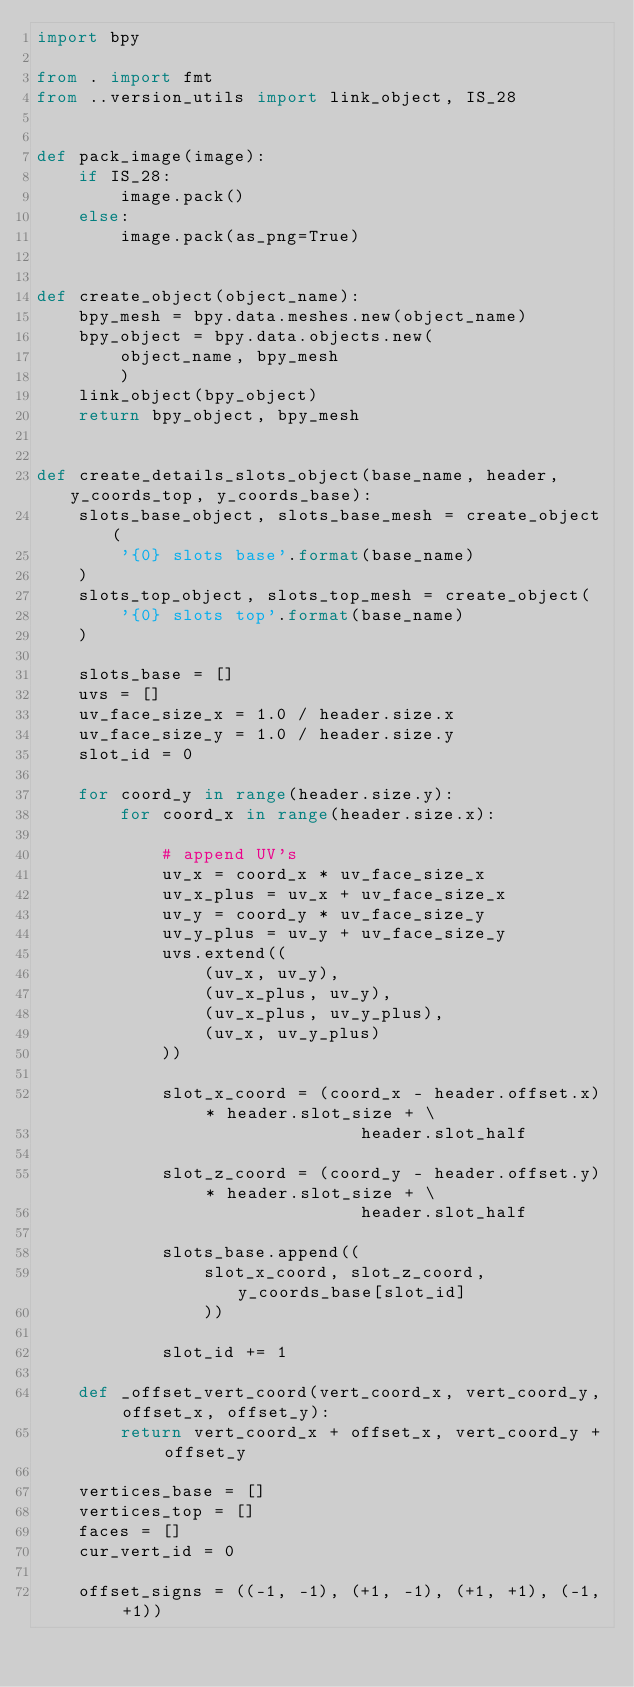<code> <loc_0><loc_0><loc_500><loc_500><_Python_>import bpy

from . import fmt
from ..version_utils import link_object, IS_28


def pack_image(image):
    if IS_28:
        image.pack()
    else:
        image.pack(as_png=True)


def create_object(object_name):
    bpy_mesh = bpy.data.meshes.new(object_name)
    bpy_object = bpy.data.objects.new(
        object_name, bpy_mesh
        )
    link_object(bpy_object)
    return bpy_object, bpy_mesh


def create_details_slots_object(base_name, header, y_coords_top, y_coords_base):
    slots_base_object, slots_base_mesh = create_object(
        '{0} slots base'.format(base_name)
    )
    slots_top_object, slots_top_mesh = create_object(
        '{0} slots top'.format(base_name)
    )

    slots_base = []
    uvs = []
    uv_face_size_x = 1.0 / header.size.x
    uv_face_size_y = 1.0 / header.size.y
    slot_id = 0

    for coord_y in range(header.size.y):
        for coord_x in range(header.size.x):

            # append UV's
            uv_x = coord_x * uv_face_size_x
            uv_x_plus = uv_x + uv_face_size_x
            uv_y = coord_y * uv_face_size_y
            uv_y_plus = uv_y + uv_face_size_y
            uvs.extend((
                (uv_x, uv_y),
                (uv_x_plus, uv_y),
                (uv_x_plus, uv_y_plus),
                (uv_x, uv_y_plus)
            ))

            slot_x_coord = (coord_x - header.offset.x) * header.slot_size + \
                               header.slot_half

            slot_z_coord = (coord_y - header.offset.y) * header.slot_size + \
                               header.slot_half

            slots_base.append((
                slot_x_coord, slot_z_coord, y_coords_base[slot_id]
                ))

            slot_id += 1

    def _offset_vert_coord(vert_coord_x, vert_coord_y, offset_x, offset_y):
        return vert_coord_x + offset_x, vert_coord_y + offset_y

    vertices_base = []
    vertices_top = []
    faces = []
    cur_vert_id = 0

    offset_signs = ((-1, -1), (+1, -1), (+1, +1), (-1, +1))
</code> 